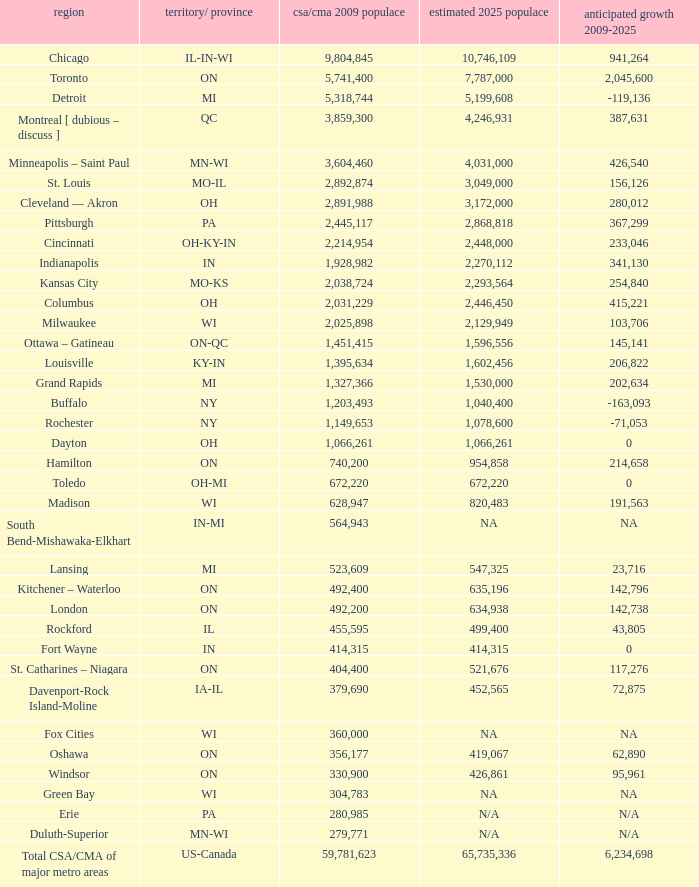What's the CSA/CMA Population in IA-IL? 379690.0. Could you parse the entire table as a dict? {'header': ['region', 'territory/ province', 'csa/cma 2009 populace', 'estimated 2025 populace', 'anticipated growth 2009-2025'], 'rows': [['Chicago', 'IL-IN-WI', '9,804,845', '10,746,109', '941,264'], ['Toronto', 'ON', '5,741,400', '7,787,000', '2,045,600'], ['Detroit', 'MI', '5,318,744', '5,199,608', '-119,136'], ['Montreal [ dubious – discuss ]', 'QC', '3,859,300', '4,246,931', '387,631'], ['Minneapolis – Saint Paul', 'MN-WI', '3,604,460', '4,031,000', '426,540'], ['St. Louis', 'MO-IL', '2,892,874', '3,049,000', '156,126'], ['Cleveland — Akron', 'OH', '2,891,988', '3,172,000', '280,012'], ['Pittsburgh', 'PA', '2,445,117', '2,868,818', '367,299'], ['Cincinnati', 'OH-KY-IN', '2,214,954', '2,448,000', '233,046'], ['Indianapolis', 'IN', '1,928,982', '2,270,112', '341,130'], ['Kansas City', 'MO-KS', '2,038,724', '2,293,564', '254,840'], ['Columbus', 'OH', '2,031,229', '2,446,450', '415,221'], ['Milwaukee', 'WI', '2,025,898', '2,129,949', '103,706'], ['Ottawa – Gatineau', 'ON-QC', '1,451,415', '1,596,556', '145,141'], ['Louisville', 'KY-IN', '1,395,634', '1,602,456', '206,822'], ['Grand Rapids', 'MI', '1,327,366', '1,530,000', '202,634'], ['Buffalo', 'NY', '1,203,493', '1,040,400', '-163,093'], ['Rochester', 'NY', '1,149,653', '1,078,600', '-71,053'], ['Dayton', 'OH', '1,066,261', '1,066,261', '0'], ['Hamilton', 'ON', '740,200', '954,858', '214,658'], ['Toledo', 'OH-MI', '672,220', '672,220', '0'], ['Madison', 'WI', '628,947', '820,483', '191,563'], ['South Bend-Mishawaka-Elkhart', 'IN-MI', '564,943', 'NA', 'NA'], ['Lansing', 'MI', '523,609', '547,325', '23,716'], ['Kitchener – Waterloo', 'ON', '492,400', '635,196', '142,796'], ['London', 'ON', '492,200', '634,938', '142,738'], ['Rockford', 'IL', '455,595', '499,400', '43,805'], ['Fort Wayne', 'IN', '414,315', '414,315', '0'], ['St. Catharines – Niagara', 'ON', '404,400', '521,676', '117,276'], ['Davenport-Rock Island-Moline', 'IA-IL', '379,690', '452,565', '72,875'], ['Fox Cities', 'WI', '360,000', 'NA', 'NA'], ['Oshawa', 'ON', '356,177', '419,067', '62,890'], ['Windsor', 'ON', '330,900', '426,861', '95,961'], ['Green Bay', 'WI', '304,783', 'NA', 'NA'], ['Erie', 'PA', '280,985', 'N/A', 'N/A'], ['Duluth-Superior', 'MN-WI', '279,771', 'N/A', 'N/A'], ['Total CSA/CMA of major metro areas', 'US-Canada', '59,781,623', '65,735,336', '6,234,698']]} 